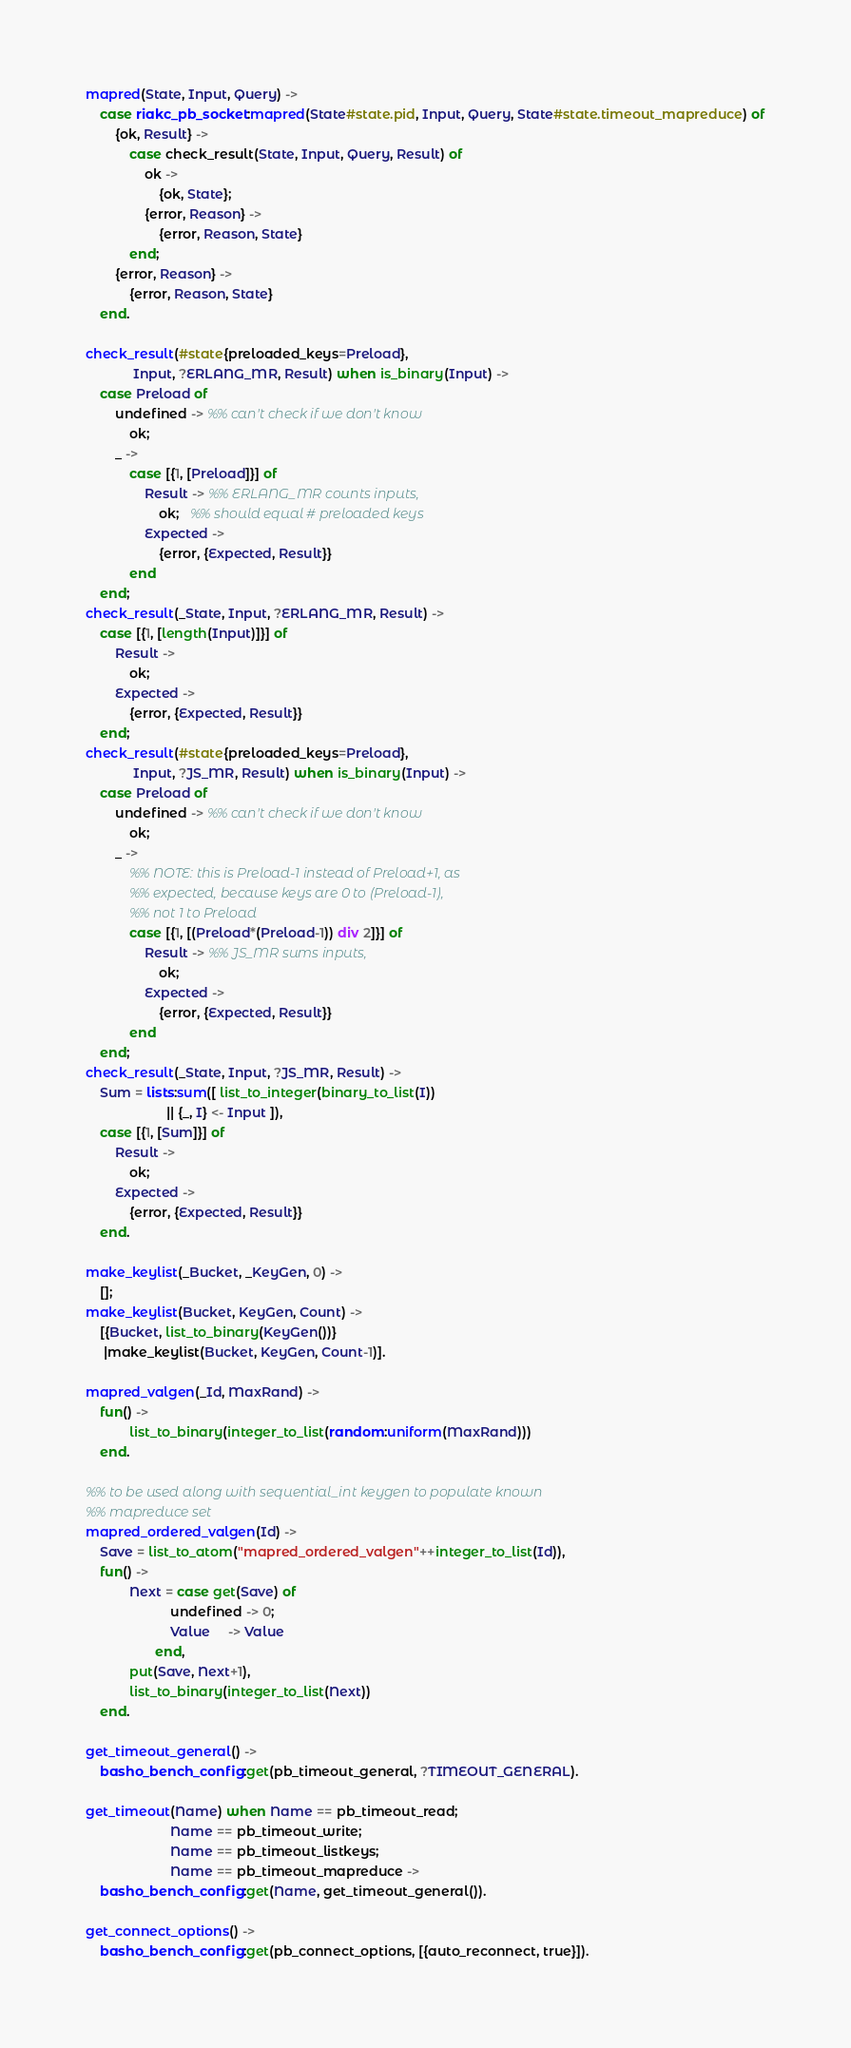<code> <loc_0><loc_0><loc_500><loc_500><_Erlang_>mapred(State, Input, Query) ->
    case riakc_pb_socket:mapred(State#state.pid, Input, Query, State#state.timeout_mapreduce) of
        {ok, Result} ->
            case check_result(State, Input, Query, Result) of
                ok ->
                    {ok, State};
                {error, Reason} ->
                    {error, Reason, State}
            end;
        {error, Reason} ->
            {error, Reason, State}
    end.

check_result(#state{preloaded_keys=Preload},
             Input, ?ERLANG_MR, Result) when is_binary(Input) ->
    case Preload of
        undefined -> %% can't check if we don't know
            ok;
        _ ->
            case [{1, [Preload]}] of
                Result -> %% ERLANG_MR counts inputs,
                    ok;   %% should equal # preloaded keys
                Expected ->
                    {error, {Expected, Result}}
            end
    end;
check_result(_State, Input, ?ERLANG_MR, Result) ->
    case [{1, [length(Input)]}] of
        Result ->
            ok;
        Expected ->
            {error, {Expected, Result}}
    end;
check_result(#state{preloaded_keys=Preload},
             Input, ?JS_MR, Result) when is_binary(Input) ->
    case Preload of
        undefined -> %% can't check if we don't know
            ok;
        _ ->
            %% NOTE: this is Preload-1 instead of Preload+1, as
            %% expected, because keys are 0 to (Preload-1),
            %% not 1 to Preload
            case [{1, [(Preload*(Preload-1)) div 2]}] of
                Result -> %% JS_MR sums inputs,
                    ok;
                Expected ->
                    {error, {Expected, Result}}
            end
    end;
check_result(_State, Input, ?JS_MR, Result) ->
    Sum = lists:sum([ list_to_integer(binary_to_list(I))
                      || {_, I} <- Input ]),
    case [{1, [Sum]}] of
        Result ->
            ok;
        Expected ->
            {error, {Expected, Result}}
    end.

make_keylist(_Bucket, _KeyGen, 0) ->
    [];
make_keylist(Bucket, KeyGen, Count) ->
    [{Bucket, list_to_binary(KeyGen())}
     |make_keylist(Bucket, KeyGen, Count-1)].

mapred_valgen(_Id, MaxRand) ->
    fun() ->
            list_to_binary(integer_to_list(random:uniform(MaxRand)))
    end.

%% to be used along with sequential_int keygen to populate known
%% mapreduce set
mapred_ordered_valgen(Id) ->
    Save = list_to_atom("mapred_ordered_valgen"++integer_to_list(Id)),
    fun() ->
            Next = case get(Save) of
                       undefined -> 0;
                       Value     -> Value
                   end,
            put(Save, Next+1),
            list_to_binary(integer_to_list(Next))
    end.

get_timeout_general() ->
    basho_bench_config:get(pb_timeout_general, ?TIMEOUT_GENERAL).

get_timeout(Name) when Name == pb_timeout_read;
                       Name == pb_timeout_write;
                       Name == pb_timeout_listkeys;
                       Name == pb_timeout_mapreduce ->
    basho_bench_config:get(Name, get_timeout_general()).

get_connect_options() ->
    basho_bench_config:get(pb_connect_options, [{auto_reconnect, true}]).
</code> 